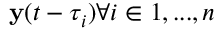<formula> <loc_0><loc_0><loc_500><loc_500>y ( t - \tau _ { i } ) \forall i \in { 1 , \dots , n }</formula> 